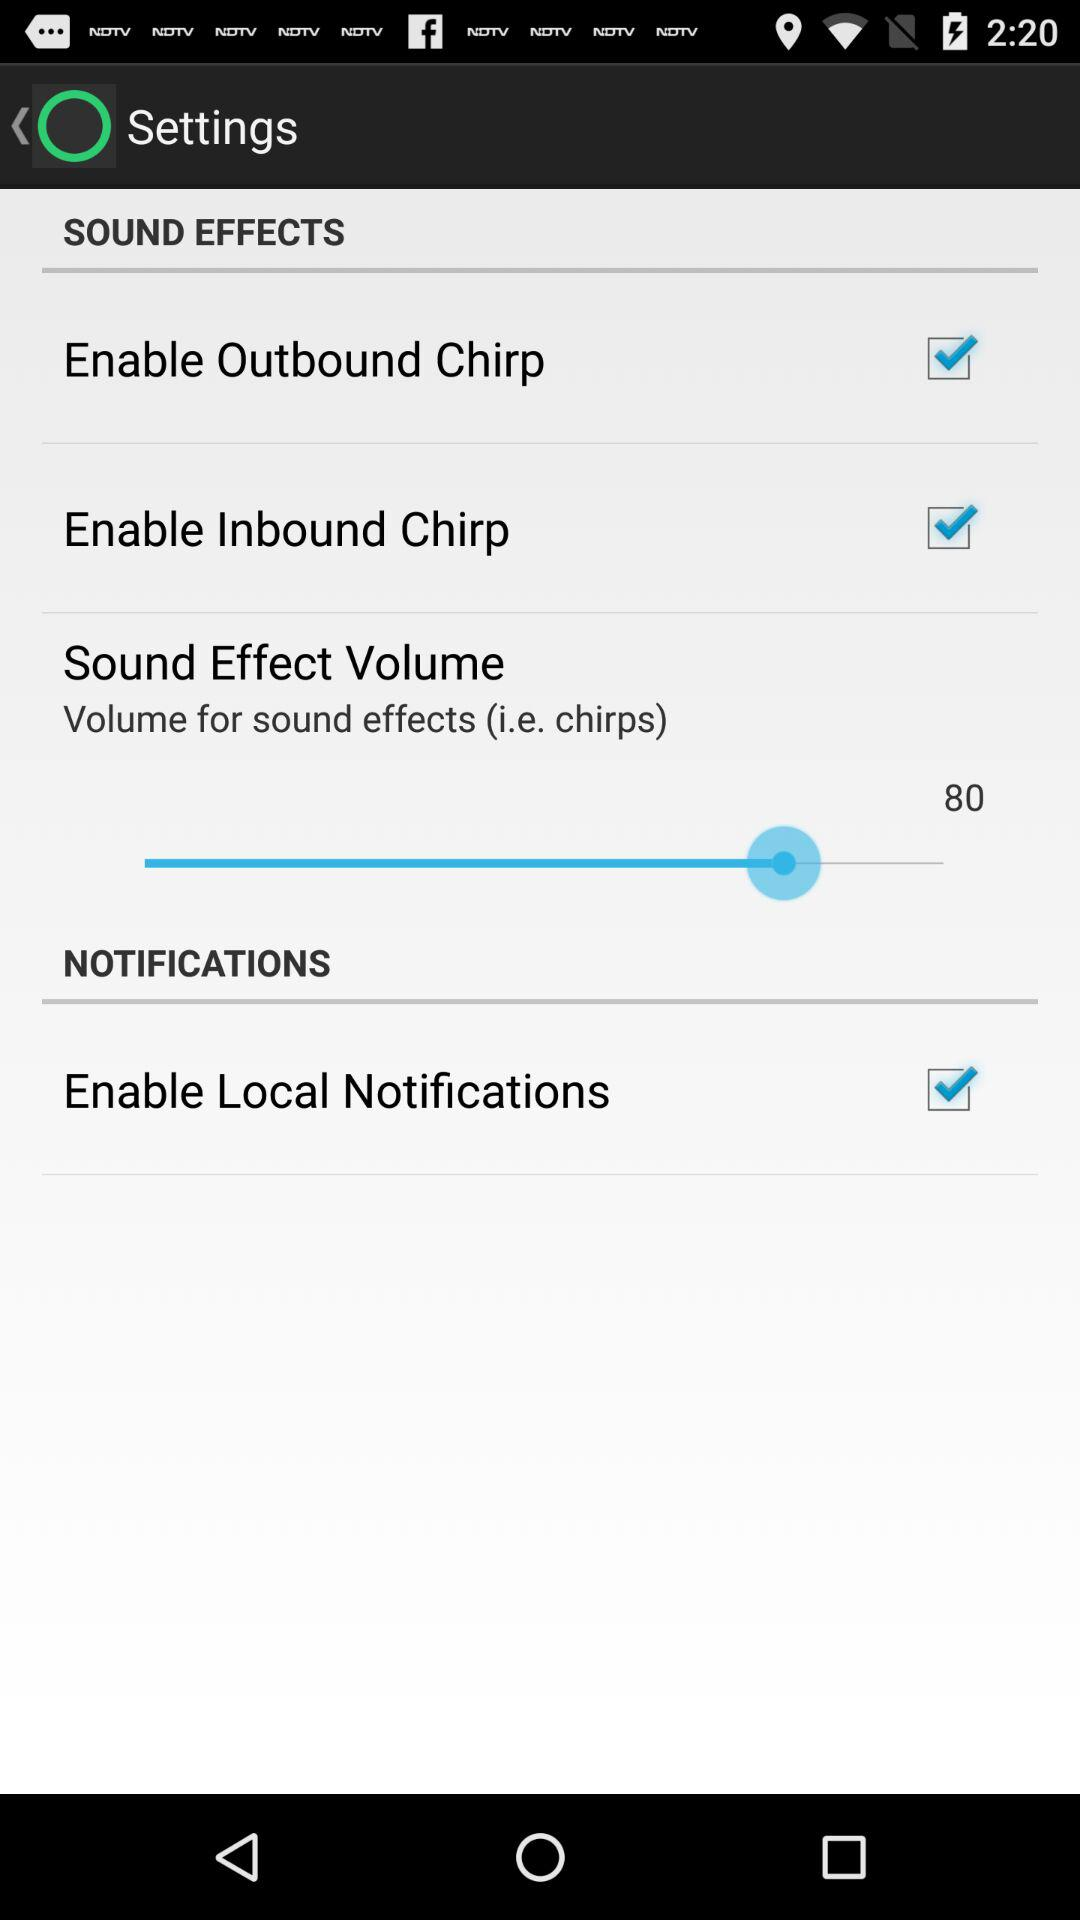What is the volume of the sound effects? The volume of the sound effect is 80. 